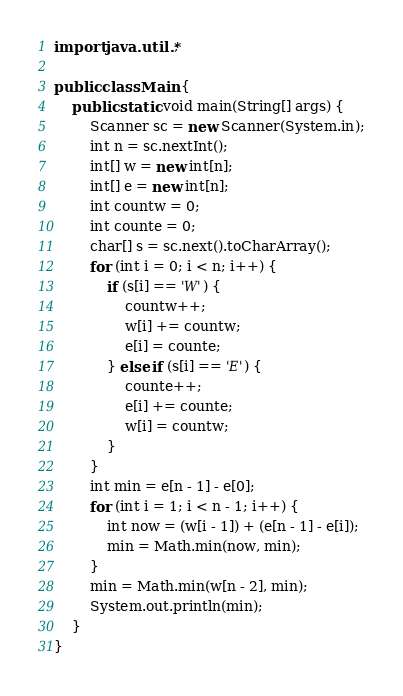Convert code to text. <code><loc_0><loc_0><loc_500><loc_500><_Java_>import java.util.*;

public class Main {
    public static void main(String[] args) {
        Scanner sc = new Scanner(System.in);
        int n = sc.nextInt();
        int[] w = new int[n];
        int[] e = new int[n];
        int countw = 0;
        int counte = 0;
        char[] s = sc.next().toCharArray();
        for (int i = 0; i < n; i++) {
            if (s[i] == 'W') {
                countw++;
                w[i] += countw;
                e[i] = counte;
            } else if (s[i] == 'E') {
                counte++;
                e[i] += counte;
                w[i] = countw;
            }
        }
        int min = e[n - 1] - e[0];
        for (int i = 1; i < n - 1; i++) {
            int now = (w[i - 1]) + (e[n - 1] - e[i]);
            min = Math.min(now, min);
        }
        min = Math.min(w[n - 2], min);
        System.out.println(min);
    }
}
</code> 